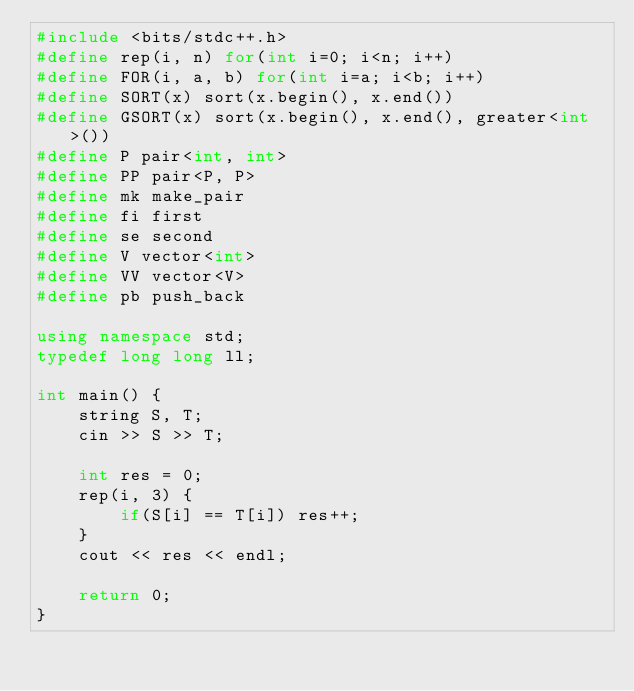Convert code to text. <code><loc_0><loc_0><loc_500><loc_500><_C++_>#include <bits/stdc++.h>
#define rep(i, n) for(int i=0; i<n; i++)
#define FOR(i, a, b) for(int i=a; i<b; i++)
#define SORT(x) sort(x.begin(), x.end())
#define GSORT(x) sort(x.begin(), x.end(), greater<int>())
#define P pair<int, int>
#define PP pair<P, P>
#define mk make_pair
#define fi first
#define se second
#define V vector<int>
#define VV vector<V>
#define pb push_back

using namespace std;
typedef long long ll;

int main() {
    string S, T;
    cin >> S >> T;

    int res = 0;
    rep(i, 3) {
        if(S[i] == T[i]) res++;
    }
    cout << res << endl;

    return 0;
}</code> 